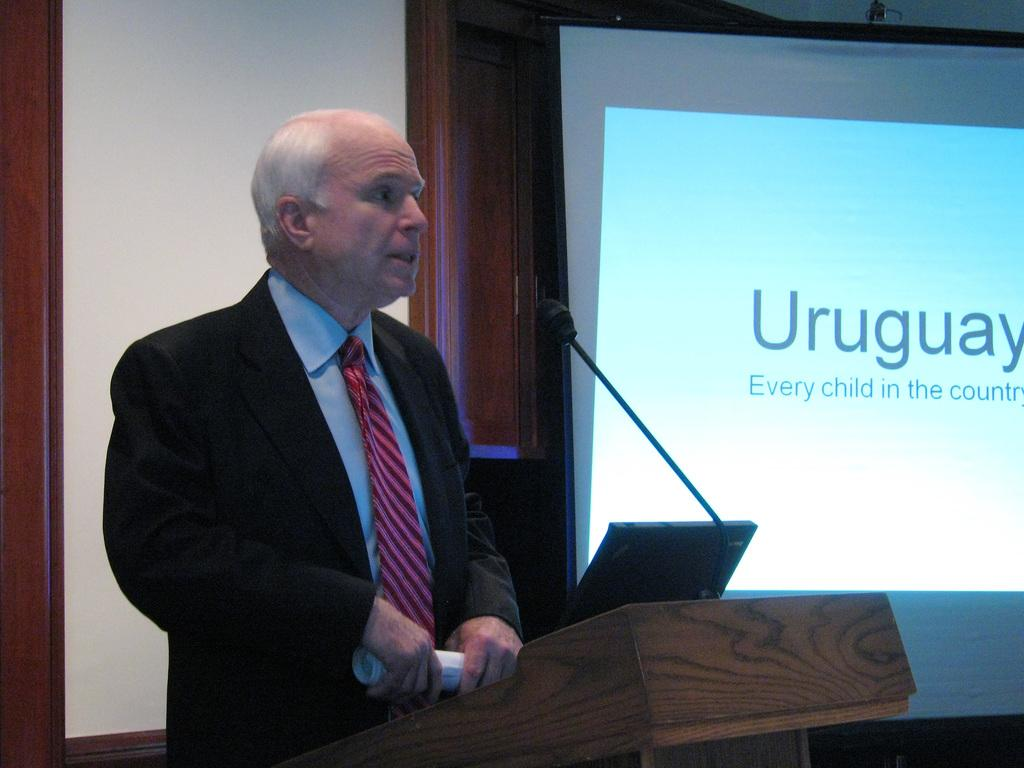What is the man in the image doing? The man is standing in the image and holding papers in his hand. What object is visible near the man? There appears to be a laptop in the image. What can be seen on the podium in the image? A microphone is present on a podium. What is displayed on the projector screen in the image? The projector screen is displaying some text. Can you see any signs of an earthquake in the image? There is no indication of an earthquake in the image. Is there a veil covering the projector screen in the image? There is no veil present in the image; the projector screen is displaying text without any covering. 